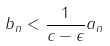<formula> <loc_0><loc_0><loc_500><loc_500>b _ { n } < \frac { 1 } { c - \epsilon } a _ { n }</formula> 